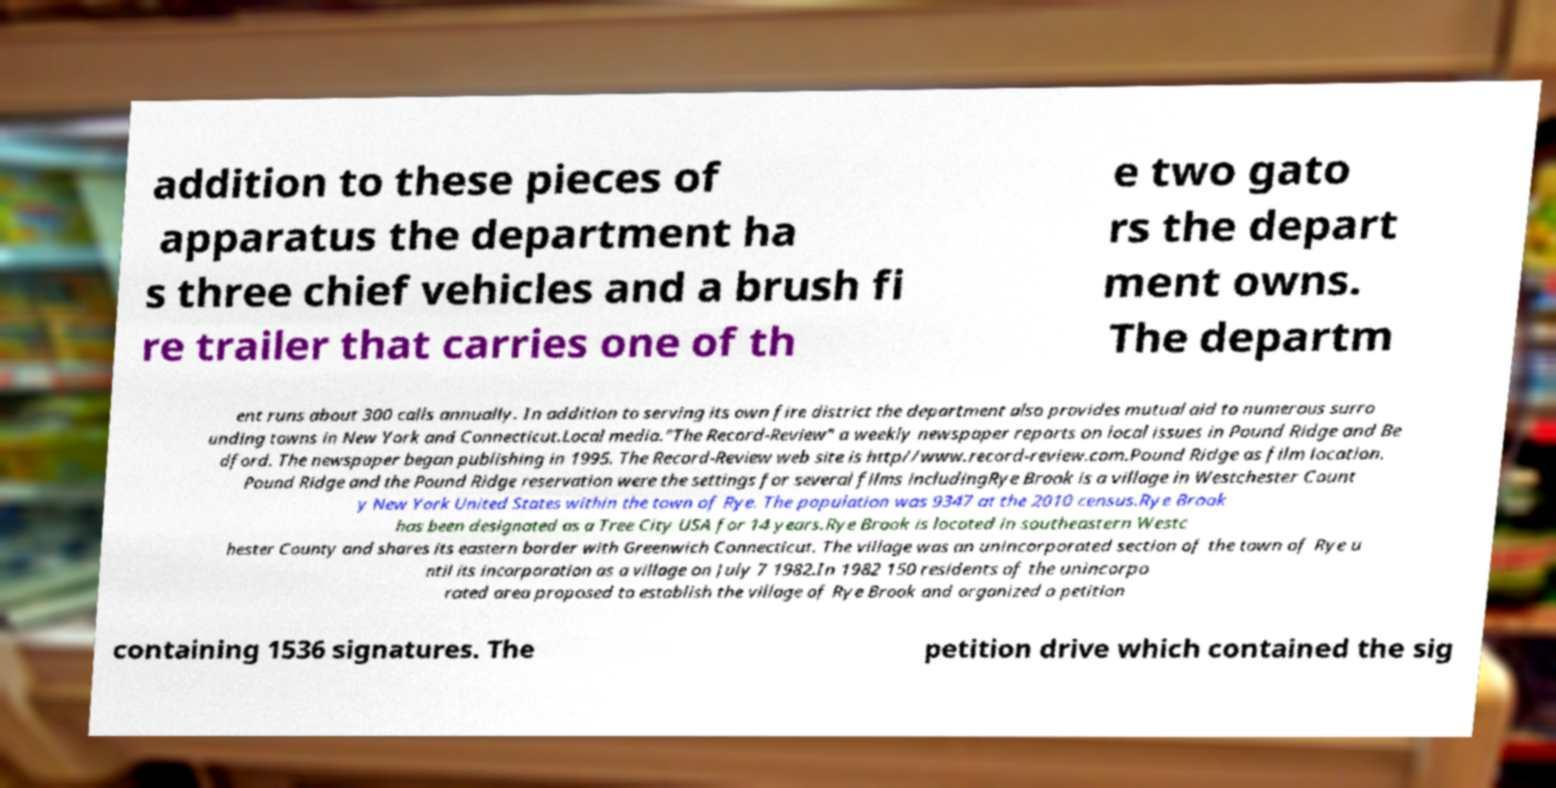Could you extract and type out the text from this image? addition to these pieces of apparatus the department ha s three chief vehicles and a brush fi re trailer that carries one of th e two gato rs the depart ment owns. The departm ent runs about 300 calls annually. In addition to serving its own fire district the department also provides mutual aid to numerous surro unding towns in New York and Connecticut.Local media."The Record-Review" a weekly newspaper reports on local issues in Pound Ridge and Be dford. The newspaper began publishing in 1995. The Record-Review web site is http//www.record-review.com.Pound Ridge as film location. Pound Ridge and the Pound Ridge reservation were the settings for several films includingRye Brook is a village in Westchester Count y New York United States within the town of Rye. The population was 9347 at the 2010 census.Rye Brook has been designated as a Tree City USA for 14 years.Rye Brook is located in southeastern Westc hester County and shares its eastern border with Greenwich Connecticut. The village was an unincorporated section of the town of Rye u ntil its incorporation as a village on July 7 1982.In 1982 150 residents of the unincorpo rated area proposed to establish the village of Rye Brook and organized a petition containing 1536 signatures. The petition drive which contained the sig 